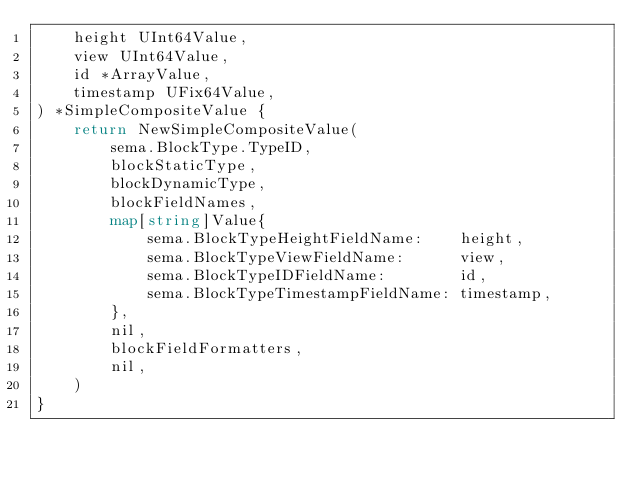<code> <loc_0><loc_0><loc_500><loc_500><_Go_>	height UInt64Value,
	view UInt64Value,
	id *ArrayValue,
	timestamp UFix64Value,
) *SimpleCompositeValue {
	return NewSimpleCompositeValue(
		sema.BlockType.TypeID,
		blockStaticType,
		blockDynamicType,
		blockFieldNames,
		map[string]Value{
			sema.BlockTypeHeightFieldName:    height,
			sema.BlockTypeViewFieldName:      view,
			sema.BlockTypeIDFieldName:        id,
			sema.BlockTypeTimestampFieldName: timestamp,
		},
		nil,
		blockFieldFormatters,
		nil,
	)
}
</code> 